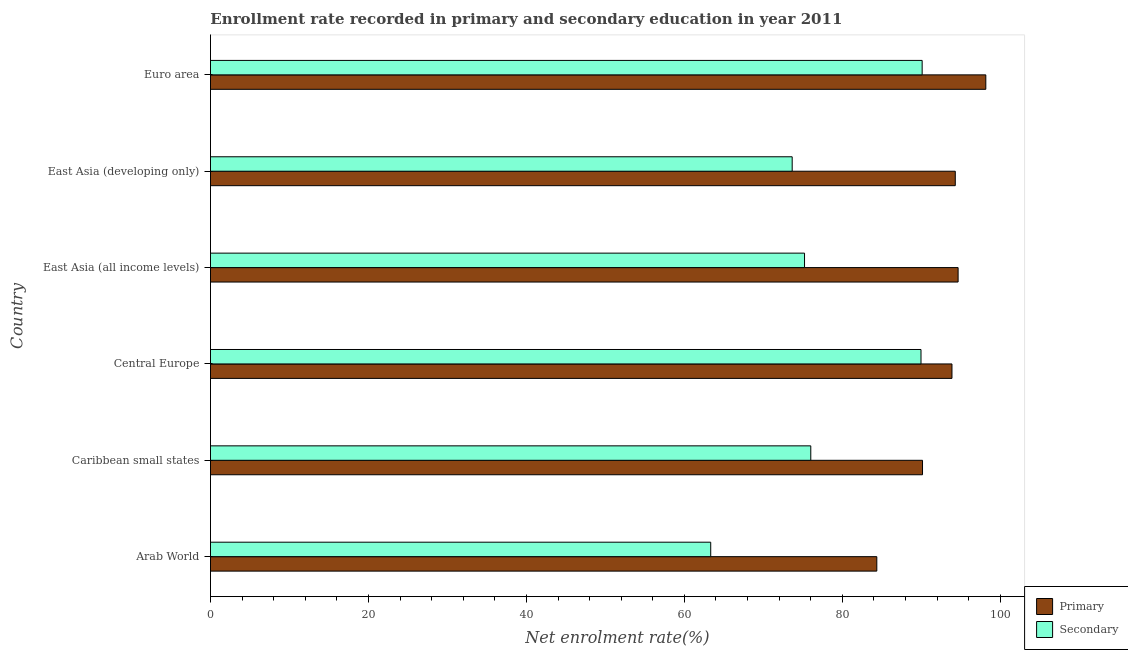Are the number of bars on each tick of the Y-axis equal?
Your answer should be compact. Yes. How many bars are there on the 3rd tick from the top?
Provide a succinct answer. 2. How many bars are there on the 2nd tick from the bottom?
Offer a terse response. 2. What is the label of the 2nd group of bars from the top?
Your answer should be compact. East Asia (developing only). In how many cases, is the number of bars for a given country not equal to the number of legend labels?
Ensure brevity in your answer.  0. What is the enrollment rate in primary education in Caribbean small states?
Offer a terse response. 90.15. Across all countries, what is the maximum enrollment rate in primary education?
Your answer should be very brief. 98.17. Across all countries, what is the minimum enrollment rate in primary education?
Offer a terse response. 84.36. In which country was the enrollment rate in secondary education maximum?
Offer a terse response. Euro area. In which country was the enrollment rate in primary education minimum?
Provide a succinct answer. Arab World. What is the total enrollment rate in primary education in the graph?
Provide a succinct answer. 555.52. What is the difference between the enrollment rate in secondary education in Central Europe and that in Euro area?
Provide a short and direct response. -0.15. What is the difference between the enrollment rate in secondary education in Central Europe and the enrollment rate in primary education in East Asia (developing only)?
Offer a terse response. -4.34. What is the average enrollment rate in secondary education per country?
Keep it short and to the point. 78.04. What is the difference between the enrollment rate in primary education and enrollment rate in secondary education in East Asia (developing only)?
Your answer should be compact. 20.65. In how many countries, is the enrollment rate in secondary education greater than 64 %?
Your answer should be very brief. 5. What is the ratio of the enrollment rate in secondary education in Arab World to that in Euro area?
Keep it short and to the point. 0.7. Is the enrollment rate in secondary education in East Asia (developing only) less than that in Euro area?
Give a very brief answer. Yes. What is the difference between the highest and the second highest enrollment rate in secondary education?
Keep it short and to the point. 0.15. What does the 1st bar from the top in Euro area represents?
Give a very brief answer. Secondary. What does the 2nd bar from the bottom in Arab World represents?
Your answer should be compact. Secondary. How many countries are there in the graph?
Offer a terse response. 6. Are the values on the major ticks of X-axis written in scientific E-notation?
Give a very brief answer. No. Does the graph contain any zero values?
Give a very brief answer. No. Does the graph contain grids?
Your answer should be very brief. No. How many legend labels are there?
Your answer should be compact. 2. What is the title of the graph?
Give a very brief answer. Enrollment rate recorded in primary and secondary education in year 2011. What is the label or title of the X-axis?
Offer a very short reply. Net enrolment rate(%). What is the Net enrolment rate(%) in Primary in Arab World?
Provide a succinct answer. 84.36. What is the Net enrolment rate(%) in Secondary in Arab World?
Offer a terse response. 63.34. What is the Net enrolment rate(%) of Primary in Caribbean small states?
Your answer should be very brief. 90.15. What is the Net enrolment rate(%) in Secondary in Caribbean small states?
Give a very brief answer. 76. What is the Net enrolment rate(%) in Primary in Central Europe?
Ensure brevity in your answer.  93.88. What is the Net enrolment rate(%) of Secondary in Central Europe?
Make the answer very short. 89.96. What is the Net enrolment rate(%) of Primary in East Asia (all income levels)?
Offer a very short reply. 94.66. What is the Net enrolment rate(%) in Secondary in East Asia (all income levels)?
Ensure brevity in your answer.  75.21. What is the Net enrolment rate(%) in Primary in East Asia (developing only)?
Make the answer very short. 94.3. What is the Net enrolment rate(%) in Secondary in East Asia (developing only)?
Ensure brevity in your answer.  73.65. What is the Net enrolment rate(%) of Primary in Euro area?
Your answer should be very brief. 98.17. What is the Net enrolment rate(%) in Secondary in Euro area?
Your answer should be very brief. 90.1. Across all countries, what is the maximum Net enrolment rate(%) in Primary?
Your answer should be compact. 98.17. Across all countries, what is the maximum Net enrolment rate(%) of Secondary?
Provide a short and direct response. 90.1. Across all countries, what is the minimum Net enrolment rate(%) in Primary?
Keep it short and to the point. 84.36. Across all countries, what is the minimum Net enrolment rate(%) in Secondary?
Offer a terse response. 63.34. What is the total Net enrolment rate(%) of Primary in the graph?
Your answer should be compact. 555.52. What is the total Net enrolment rate(%) of Secondary in the graph?
Make the answer very short. 468.27. What is the difference between the Net enrolment rate(%) in Primary in Arab World and that in Caribbean small states?
Your answer should be very brief. -5.79. What is the difference between the Net enrolment rate(%) in Secondary in Arab World and that in Caribbean small states?
Your answer should be very brief. -12.67. What is the difference between the Net enrolment rate(%) of Primary in Arab World and that in Central Europe?
Make the answer very short. -9.52. What is the difference between the Net enrolment rate(%) in Secondary in Arab World and that in Central Europe?
Provide a succinct answer. -26.62. What is the difference between the Net enrolment rate(%) of Primary in Arab World and that in East Asia (all income levels)?
Offer a very short reply. -10.29. What is the difference between the Net enrolment rate(%) in Secondary in Arab World and that in East Asia (all income levels)?
Offer a very short reply. -11.88. What is the difference between the Net enrolment rate(%) of Primary in Arab World and that in East Asia (developing only)?
Your response must be concise. -9.93. What is the difference between the Net enrolment rate(%) of Secondary in Arab World and that in East Asia (developing only)?
Ensure brevity in your answer.  -10.32. What is the difference between the Net enrolment rate(%) of Primary in Arab World and that in Euro area?
Your answer should be very brief. -13.8. What is the difference between the Net enrolment rate(%) of Secondary in Arab World and that in Euro area?
Make the answer very short. -26.77. What is the difference between the Net enrolment rate(%) in Primary in Caribbean small states and that in Central Europe?
Keep it short and to the point. -3.73. What is the difference between the Net enrolment rate(%) of Secondary in Caribbean small states and that in Central Europe?
Your response must be concise. -13.95. What is the difference between the Net enrolment rate(%) in Primary in Caribbean small states and that in East Asia (all income levels)?
Offer a very short reply. -4.5. What is the difference between the Net enrolment rate(%) of Secondary in Caribbean small states and that in East Asia (all income levels)?
Keep it short and to the point. 0.79. What is the difference between the Net enrolment rate(%) in Primary in Caribbean small states and that in East Asia (developing only)?
Keep it short and to the point. -4.15. What is the difference between the Net enrolment rate(%) of Secondary in Caribbean small states and that in East Asia (developing only)?
Keep it short and to the point. 2.35. What is the difference between the Net enrolment rate(%) of Primary in Caribbean small states and that in Euro area?
Offer a very short reply. -8.01. What is the difference between the Net enrolment rate(%) of Secondary in Caribbean small states and that in Euro area?
Keep it short and to the point. -14.1. What is the difference between the Net enrolment rate(%) in Primary in Central Europe and that in East Asia (all income levels)?
Provide a short and direct response. -0.78. What is the difference between the Net enrolment rate(%) in Secondary in Central Europe and that in East Asia (all income levels)?
Your answer should be very brief. 14.75. What is the difference between the Net enrolment rate(%) in Primary in Central Europe and that in East Asia (developing only)?
Your answer should be very brief. -0.42. What is the difference between the Net enrolment rate(%) of Secondary in Central Europe and that in East Asia (developing only)?
Provide a short and direct response. 16.31. What is the difference between the Net enrolment rate(%) in Primary in Central Europe and that in Euro area?
Keep it short and to the point. -4.29. What is the difference between the Net enrolment rate(%) of Secondary in Central Europe and that in Euro area?
Offer a terse response. -0.15. What is the difference between the Net enrolment rate(%) of Primary in East Asia (all income levels) and that in East Asia (developing only)?
Offer a very short reply. 0.36. What is the difference between the Net enrolment rate(%) of Secondary in East Asia (all income levels) and that in East Asia (developing only)?
Your answer should be very brief. 1.56. What is the difference between the Net enrolment rate(%) of Primary in East Asia (all income levels) and that in Euro area?
Offer a very short reply. -3.51. What is the difference between the Net enrolment rate(%) of Secondary in East Asia (all income levels) and that in Euro area?
Your answer should be very brief. -14.89. What is the difference between the Net enrolment rate(%) in Primary in East Asia (developing only) and that in Euro area?
Your response must be concise. -3.87. What is the difference between the Net enrolment rate(%) of Secondary in East Asia (developing only) and that in Euro area?
Your answer should be very brief. -16.45. What is the difference between the Net enrolment rate(%) of Primary in Arab World and the Net enrolment rate(%) of Secondary in Caribbean small states?
Offer a terse response. 8.36. What is the difference between the Net enrolment rate(%) of Primary in Arab World and the Net enrolment rate(%) of Secondary in Central Europe?
Keep it short and to the point. -5.59. What is the difference between the Net enrolment rate(%) of Primary in Arab World and the Net enrolment rate(%) of Secondary in East Asia (all income levels)?
Make the answer very short. 9.15. What is the difference between the Net enrolment rate(%) of Primary in Arab World and the Net enrolment rate(%) of Secondary in East Asia (developing only)?
Give a very brief answer. 10.71. What is the difference between the Net enrolment rate(%) of Primary in Arab World and the Net enrolment rate(%) of Secondary in Euro area?
Your answer should be very brief. -5.74. What is the difference between the Net enrolment rate(%) of Primary in Caribbean small states and the Net enrolment rate(%) of Secondary in Central Europe?
Your answer should be very brief. 0.19. What is the difference between the Net enrolment rate(%) of Primary in Caribbean small states and the Net enrolment rate(%) of Secondary in East Asia (all income levels)?
Ensure brevity in your answer.  14.94. What is the difference between the Net enrolment rate(%) in Primary in Caribbean small states and the Net enrolment rate(%) in Secondary in East Asia (developing only)?
Your response must be concise. 16.5. What is the difference between the Net enrolment rate(%) in Primary in Caribbean small states and the Net enrolment rate(%) in Secondary in Euro area?
Offer a terse response. 0.05. What is the difference between the Net enrolment rate(%) of Primary in Central Europe and the Net enrolment rate(%) of Secondary in East Asia (all income levels)?
Keep it short and to the point. 18.67. What is the difference between the Net enrolment rate(%) of Primary in Central Europe and the Net enrolment rate(%) of Secondary in East Asia (developing only)?
Your answer should be compact. 20.23. What is the difference between the Net enrolment rate(%) of Primary in Central Europe and the Net enrolment rate(%) of Secondary in Euro area?
Make the answer very short. 3.78. What is the difference between the Net enrolment rate(%) in Primary in East Asia (all income levels) and the Net enrolment rate(%) in Secondary in East Asia (developing only)?
Your answer should be very brief. 21.01. What is the difference between the Net enrolment rate(%) of Primary in East Asia (all income levels) and the Net enrolment rate(%) of Secondary in Euro area?
Provide a short and direct response. 4.55. What is the difference between the Net enrolment rate(%) of Primary in East Asia (developing only) and the Net enrolment rate(%) of Secondary in Euro area?
Your answer should be compact. 4.19. What is the average Net enrolment rate(%) of Primary per country?
Give a very brief answer. 92.59. What is the average Net enrolment rate(%) of Secondary per country?
Give a very brief answer. 78.04. What is the difference between the Net enrolment rate(%) in Primary and Net enrolment rate(%) in Secondary in Arab World?
Keep it short and to the point. 21.03. What is the difference between the Net enrolment rate(%) of Primary and Net enrolment rate(%) of Secondary in Caribbean small states?
Your response must be concise. 14.15. What is the difference between the Net enrolment rate(%) in Primary and Net enrolment rate(%) in Secondary in Central Europe?
Provide a succinct answer. 3.92. What is the difference between the Net enrolment rate(%) of Primary and Net enrolment rate(%) of Secondary in East Asia (all income levels)?
Give a very brief answer. 19.44. What is the difference between the Net enrolment rate(%) of Primary and Net enrolment rate(%) of Secondary in East Asia (developing only)?
Your answer should be very brief. 20.65. What is the difference between the Net enrolment rate(%) in Primary and Net enrolment rate(%) in Secondary in Euro area?
Ensure brevity in your answer.  8.06. What is the ratio of the Net enrolment rate(%) in Primary in Arab World to that in Caribbean small states?
Make the answer very short. 0.94. What is the ratio of the Net enrolment rate(%) in Primary in Arab World to that in Central Europe?
Make the answer very short. 0.9. What is the ratio of the Net enrolment rate(%) in Secondary in Arab World to that in Central Europe?
Provide a succinct answer. 0.7. What is the ratio of the Net enrolment rate(%) of Primary in Arab World to that in East Asia (all income levels)?
Give a very brief answer. 0.89. What is the ratio of the Net enrolment rate(%) of Secondary in Arab World to that in East Asia (all income levels)?
Your answer should be very brief. 0.84. What is the ratio of the Net enrolment rate(%) in Primary in Arab World to that in East Asia (developing only)?
Keep it short and to the point. 0.89. What is the ratio of the Net enrolment rate(%) of Secondary in Arab World to that in East Asia (developing only)?
Make the answer very short. 0.86. What is the ratio of the Net enrolment rate(%) in Primary in Arab World to that in Euro area?
Offer a terse response. 0.86. What is the ratio of the Net enrolment rate(%) of Secondary in Arab World to that in Euro area?
Your answer should be very brief. 0.7. What is the ratio of the Net enrolment rate(%) in Primary in Caribbean small states to that in Central Europe?
Your response must be concise. 0.96. What is the ratio of the Net enrolment rate(%) in Secondary in Caribbean small states to that in Central Europe?
Your answer should be compact. 0.84. What is the ratio of the Net enrolment rate(%) in Primary in Caribbean small states to that in East Asia (all income levels)?
Give a very brief answer. 0.95. What is the ratio of the Net enrolment rate(%) of Secondary in Caribbean small states to that in East Asia (all income levels)?
Offer a very short reply. 1.01. What is the ratio of the Net enrolment rate(%) of Primary in Caribbean small states to that in East Asia (developing only)?
Your answer should be very brief. 0.96. What is the ratio of the Net enrolment rate(%) in Secondary in Caribbean small states to that in East Asia (developing only)?
Your answer should be compact. 1.03. What is the ratio of the Net enrolment rate(%) in Primary in Caribbean small states to that in Euro area?
Your answer should be very brief. 0.92. What is the ratio of the Net enrolment rate(%) of Secondary in Caribbean small states to that in Euro area?
Give a very brief answer. 0.84. What is the ratio of the Net enrolment rate(%) in Secondary in Central Europe to that in East Asia (all income levels)?
Provide a short and direct response. 1.2. What is the ratio of the Net enrolment rate(%) in Primary in Central Europe to that in East Asia (developing only)?
Offer a terse response. 1. What is the ratio of the Net enrolment rate(%) in Secondary in Central Europe to that in East Asia (developing only)?
Provide a short and direct response. 1.22. What is the ratio of the Net enrolment rate(%) of Primary in Central Europe to that in Euro area?
Ensure brevity in your answer.  0.96. What is the ratio of the Net enrolment rate(%) of Primary in East Asia (all income levels) to that in East Asia (developing only)?
Make the answer very short. 1. What is the ratio of the Net enrolment rate(%) in Secondary in East Asia (all income levels) to that in East Asia (developing only)?
Your answer should be very brief. 1.02. What is the ratio of the Net enrolment rate(%) in Primary in East Asia (all income levels) to that in Euro area?
Make the answer very short. 0.96. What is the ratio of the Net enrolment rate(%) of Secondary in East Asia (all income levels) to that in Euro area?
Provide a short and direct response. 0.83. What is the ratio of the Net enrolment rate(%) of Primary in East Asia (developing only) to that in Euro area?
Offer a very short reply. 0.96. What is the ratio of the Net enrolment rate(%) in Secondary in East Asia (developing only) to that in Euro area?
Offer a very short reply. 0.82. What is the difference between the highest and the second highest Net enrolment rate(%) in Primary?
Make the answer very short. 3.51. What is the difference between the highest and the second highest Net enrolment rate(%) of Secondary?
Ensure brevity in your answer.  0.15. What is the difference between the highest and the lowest Net enrolment rate(%) in Primary?
Offer a terse response. 13.8. What is the difference between the highest and the lowest Net enrolment rate(%) of Secondary?
Your response must be concise. 26.77. 